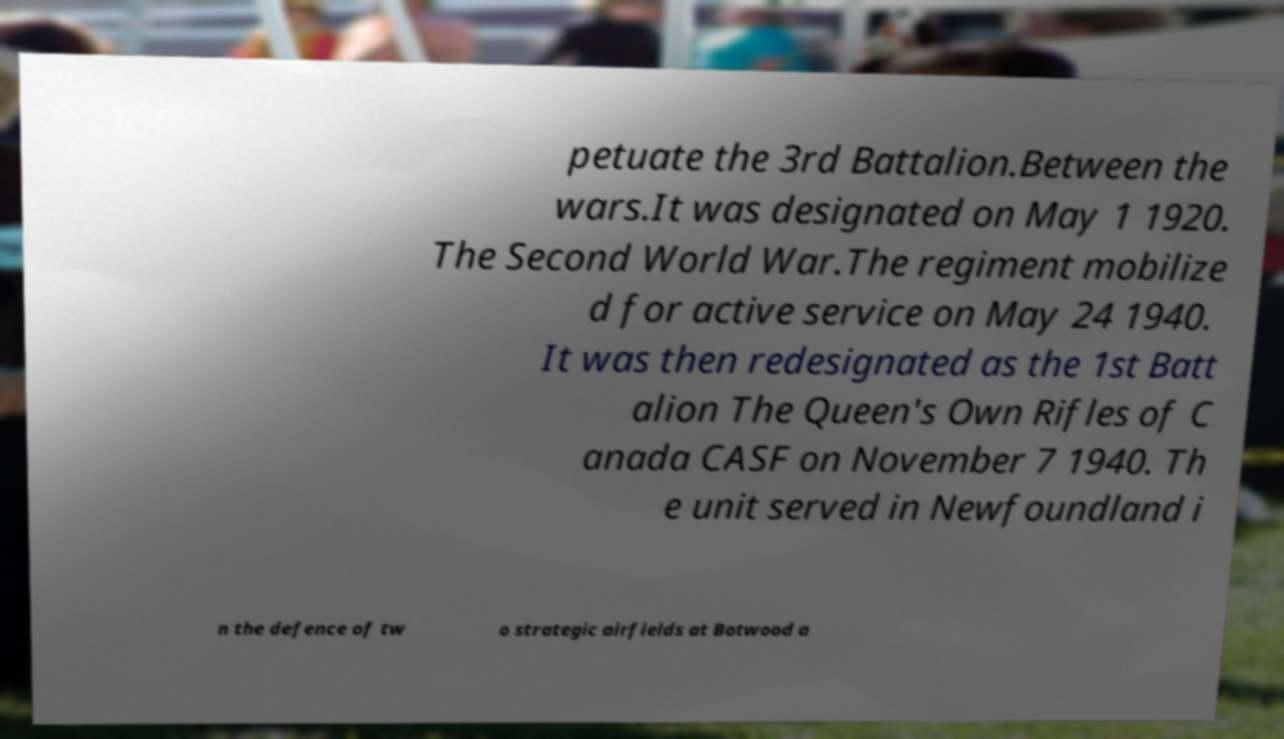What messages or text are displayed in this image? I need them in a readable, typed format. petuate the 3rd Battalion.Between the wars.It was designated on May 1 1920. The Second World War.The regiment mobilize d for active service on May 24 1940. It was then redesignated as the 1st Batt alion The Queen's Own Rifles of C anada CASF on November 7 1940. Th e unit served in Newfoundland i n the defence of tw o strategic airfields at Botwood a 